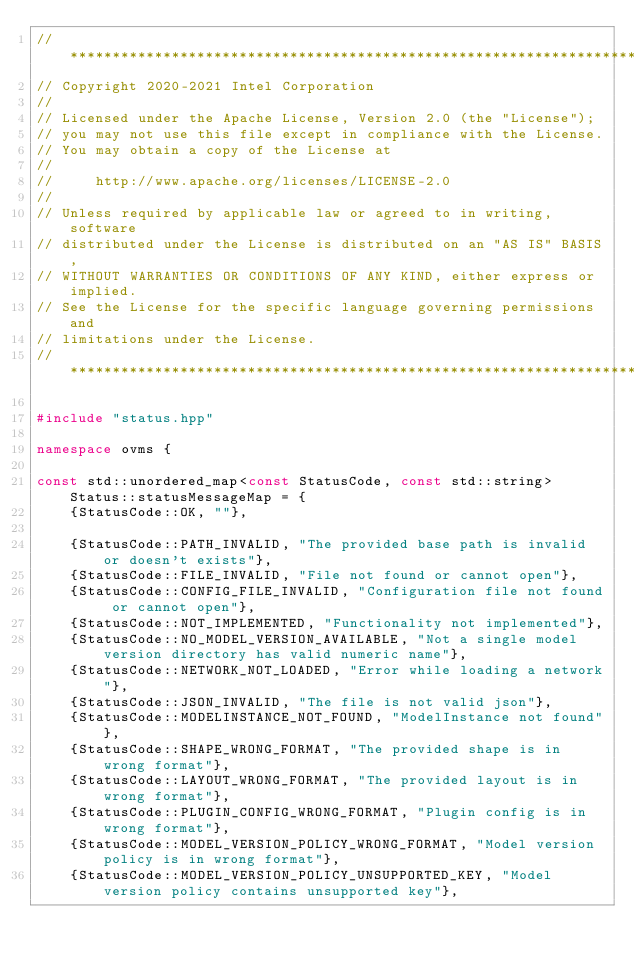<code> <loc_0><loc_0><loc_500><loc_500><_C++_>//*****************************************************************************
// Copyright 2020-2021 Intel Corporation
//
// Licensed under the Apache License, Version 2.0 (the "License");
// you may not use this file except in compliance with the License.
// You may obtain a copy of the License at
//
//     http://www.apache.org/licenses/LICENSE-2.0
//
// Unless required by applicable law or agreed to in writing, software
// distributed under the License is distributed on an "AS IS" BASIS,
// WITHOUT WARRANTIES OR CONDITIONS OF ANY KIND, either express or implied.
// See the License for the specific language governing permissions and
// limitations under the License.
//*****************************************************************************

#include "status.hpp"

namespace ovms {

const std::unordered_map<const StatusCode, const std::string> Status::statusMessageMap = {
    {StatusCode::OK, ""},

    {StatusCode::PATH_INVALID, "The provided base path is invalid or doesn't exists"},
    {StatusCode::FILE_INVALID, "File not found or cannot open"},
    {StatusCode::CONFIG_FILE_INVALID, "Configuration file not found or cannot open"},
    {StatusCode::NOT_IMPLEMENTED, "Functionality not implemented"},
    {StatusCode::NO_MODEL_VERSION_AVAILABLE, "Not a single model version directory has valid numeric name"},
    {StatusCode::NETWORK_NOT_LOADED, "Error while loading a network"},
    {StatusCode::JSON_INVALID, "The file is not valid json"},
    {StatusCode::MODELINSTANCE_NOT_FOUND, "ModelInstance not found"},
    {StatusCode::SHAPE_WRONG_FORMAT, "The provided shape is in wrong format"},
    {StatusCode::LAYOUT_WRONG_FORMAT, "The provided layout is in wrong format"},
    {StatusCode::PLUGIN_CONFIG_WRONG_FORMAT, "Plugin config is in wrong format"},
    {StatusCode::MODEL_VERSION_POLICY_WRONG_FORMAT, "Model version policy is in wrong format"},
    {StatusCode::MODEL_VERSION_POLICY_UNSUPPORTED_KEY, "Model version policy contains unsupported key"},</code> 